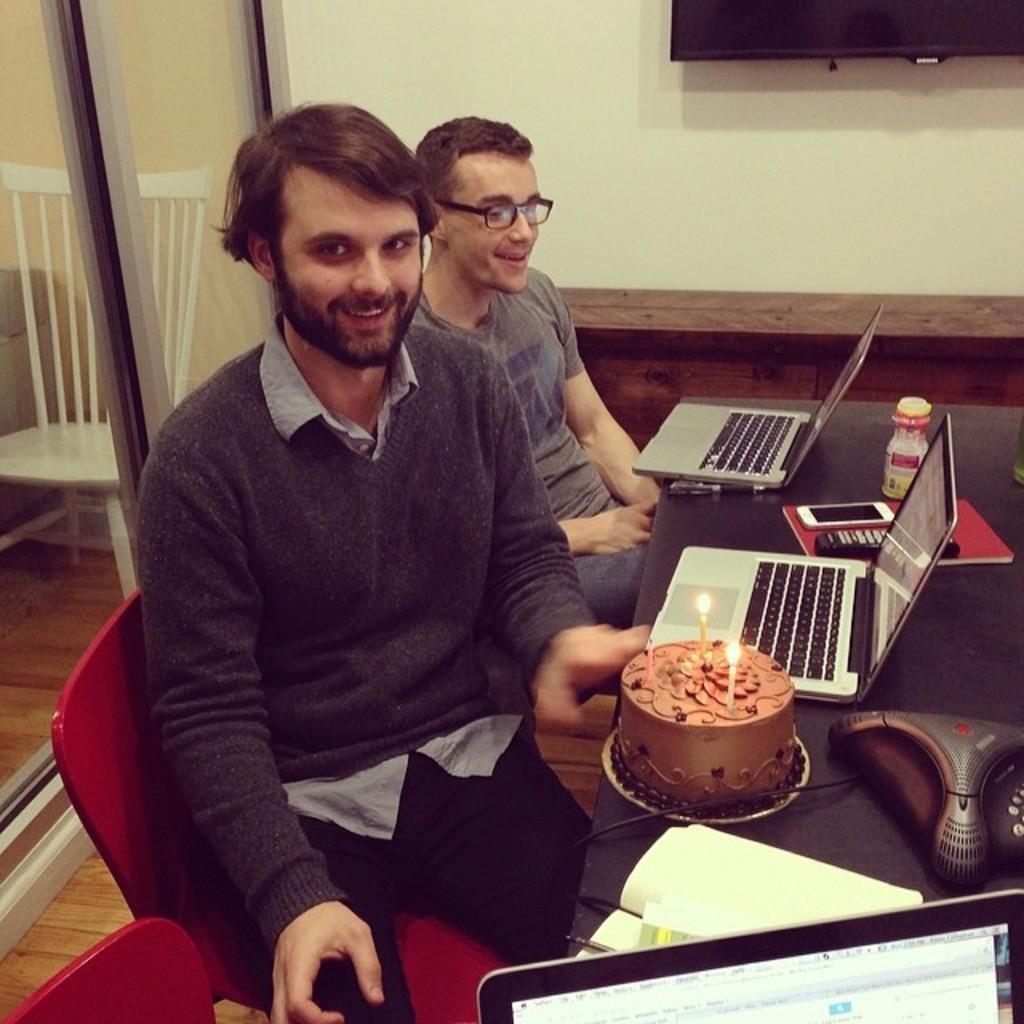In one or two sentences, can you explain what this image depicts? Two men are sitting in chairs at a table. There are laptops in front of them. A man is keeping a cake in front of him. There are some other electronic gadgets on the table. 